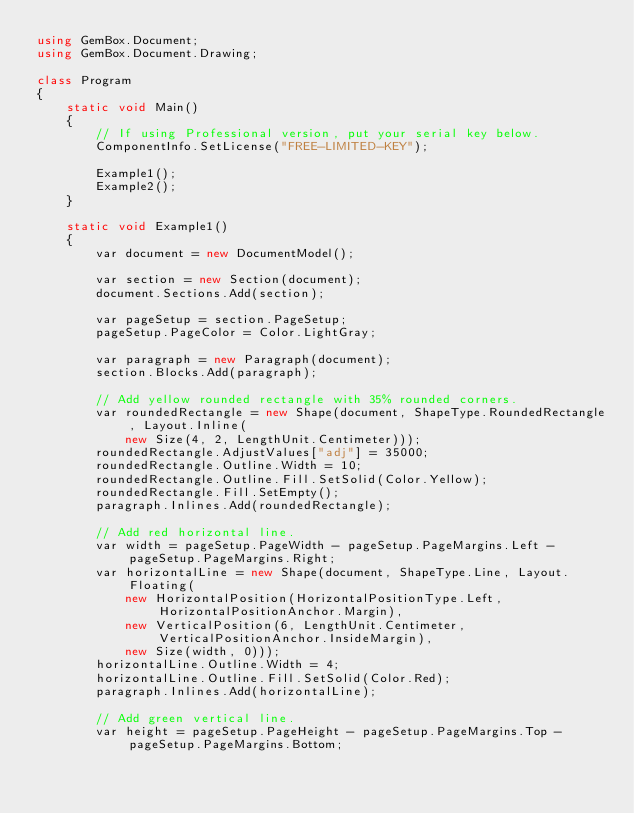<code> <loc_0><loc_0><loc_500><loc_500><_C#_>using GemBox.Document;
using GemBox.Document.Drawing;

class Program
{
    static void Main()
    {
        // If using Professional version, put your serial key below.
        ComponentInfo.SetLicense("FREE-LIMITED-KEY");

        Example1();
        Example2();
    }

    static void Example1()
    {
        var document = new DocumentModel();

        var section = new Section(document);
        document.Sections.Add(section);

        var pageSetup = section.PageSetup;
        pageSetup.PageColor = Color.LightGray;

        var paragraph = new Paragraph(document);
        section.Blocks.Add(paragraph);

        // Add yellow rounded rectangle with 35% rounded corners.
        var roundedRectangle = new Shape(document, ShapeType.RoundedRectangle, Layout.Inline(
            new Size(4, 2, LengthUnit.Centimeter)));
        roundedRectangle.AdjustValues["adj"] = 35000;
        roundedRectangle.Outline.Width = 10;
        roundedRectangle.Outline.Fill.SetSolid(Color.Yellow);
        roundedRectangle.Fill.SetEmpty();
        paragraph.Inlines.Add(roundedRectangle);

        // Add red horizontal line.
        var width = pageSetup.PageWidth - pageSetup.PageMargins.Left - pageSetup.PageMargins.Right;
        var horizontalLine = new Shape(document, ShapeType.Line, Layout.Floating(
            new HorizontalPosition(HorizontalPositionType.Left, HorizontalPositionAnchor.Margin),
            new VerticalPosition(6, LengthUnit.Centimeter, VerticalPositionAnchor.InsideMargin),
            new Size(width, 0)));
        horizontalLine.Outline.Width = 4;
        horizontalLine.Outline.Fill.SetSolid(Color.Red);
        paragraph.Inlines.Add(horizontalLine);

        // Add green vertical line.
        var height = pageSetup.PageHeight - pageSetup.PageMargins.Top - pageSetup.PageMargins.Bottom;</code> 